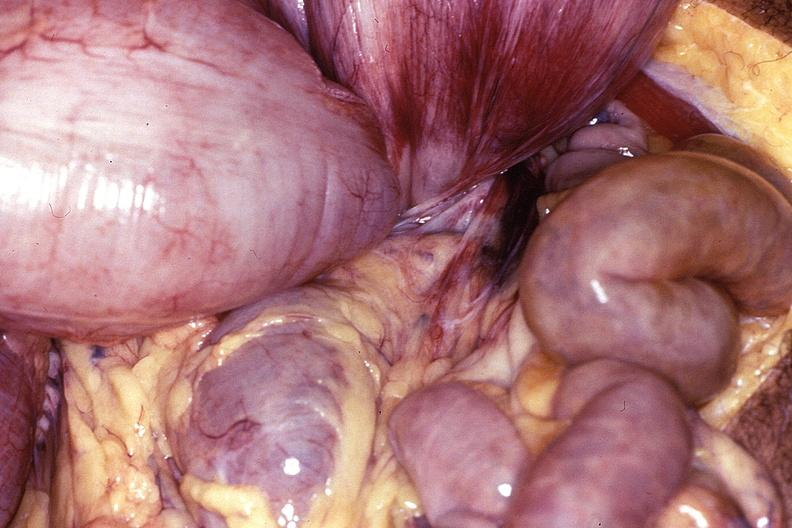does this image show intestine, volvulus?
Answer the question using a single word or phrase. Yes 